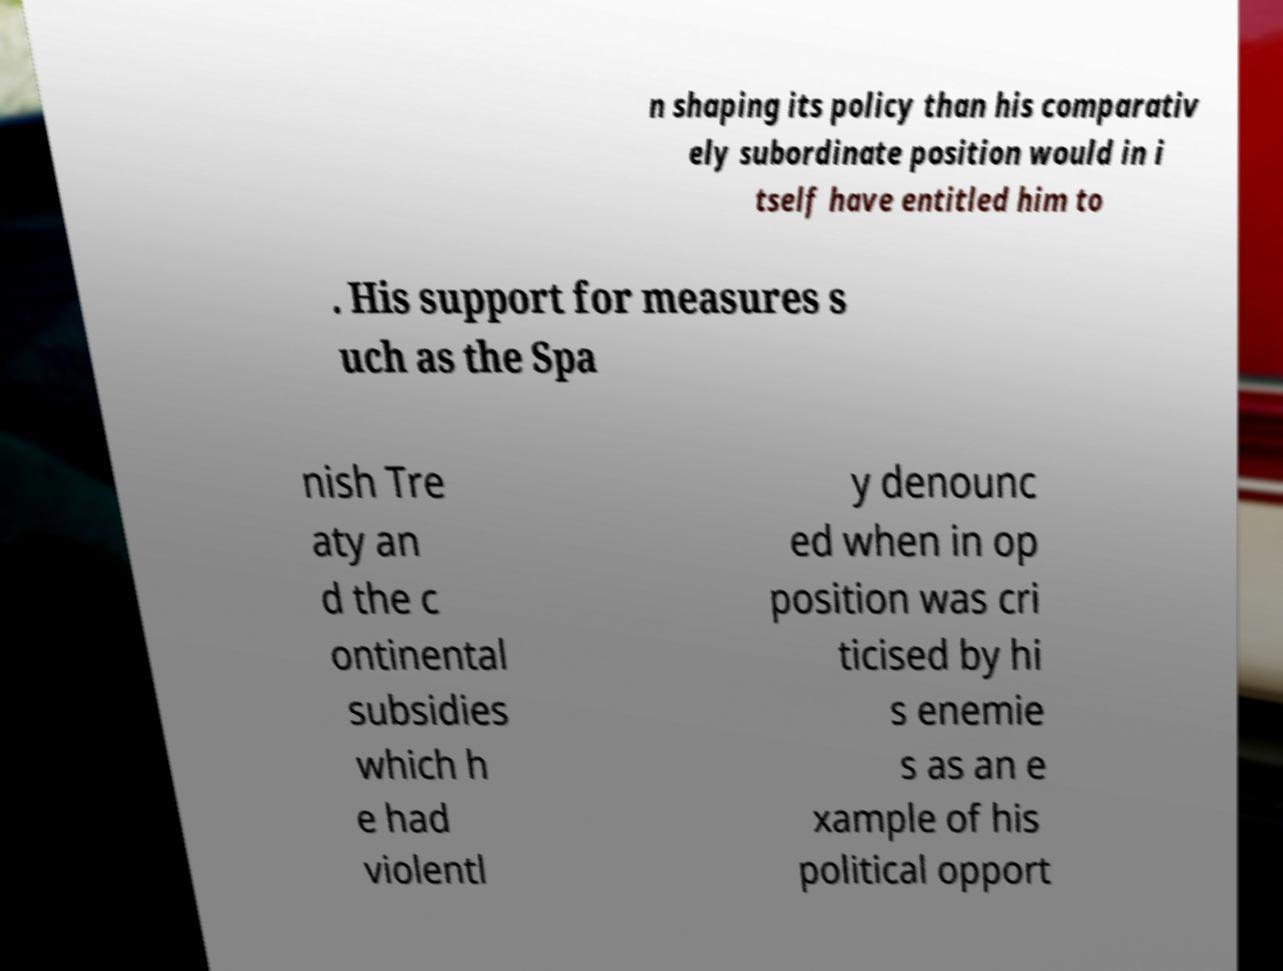What messages or text are displayed in this image? I need them in a readable, typed format. n shaping its policy than his comparativ ely subordinate position would in i tself have entitled him to . His support for measures s uch as the Spa nish Tre aty an d the c ontinental subsidies which h e had violentl y denounc ed when in op position was cri ticised by hi s enemie s as an e xample of his political opport 